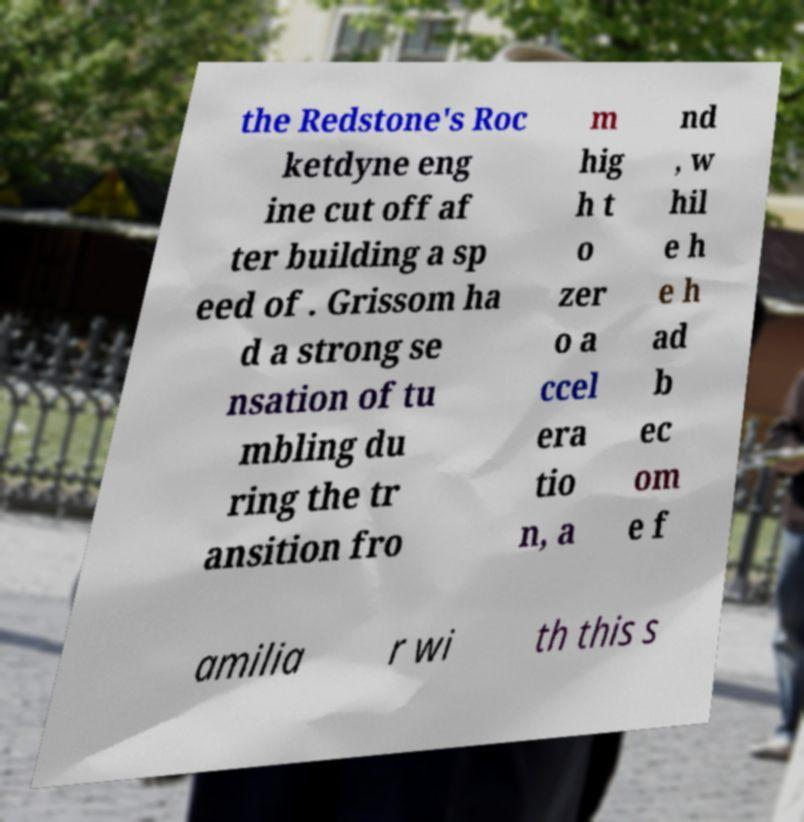I need the written content from this picture converted into text. Can you do that? the Redstone's Roc ketdyne eng ine cut off af ter building a sp eed of . Grissom ha d a strong se nsation of tu mbling du ring the tr ansition fro m hig h t o zer o a ccel era tio n, a nd , w hil e h e h ad b ec om e f amilia r wi th this s 